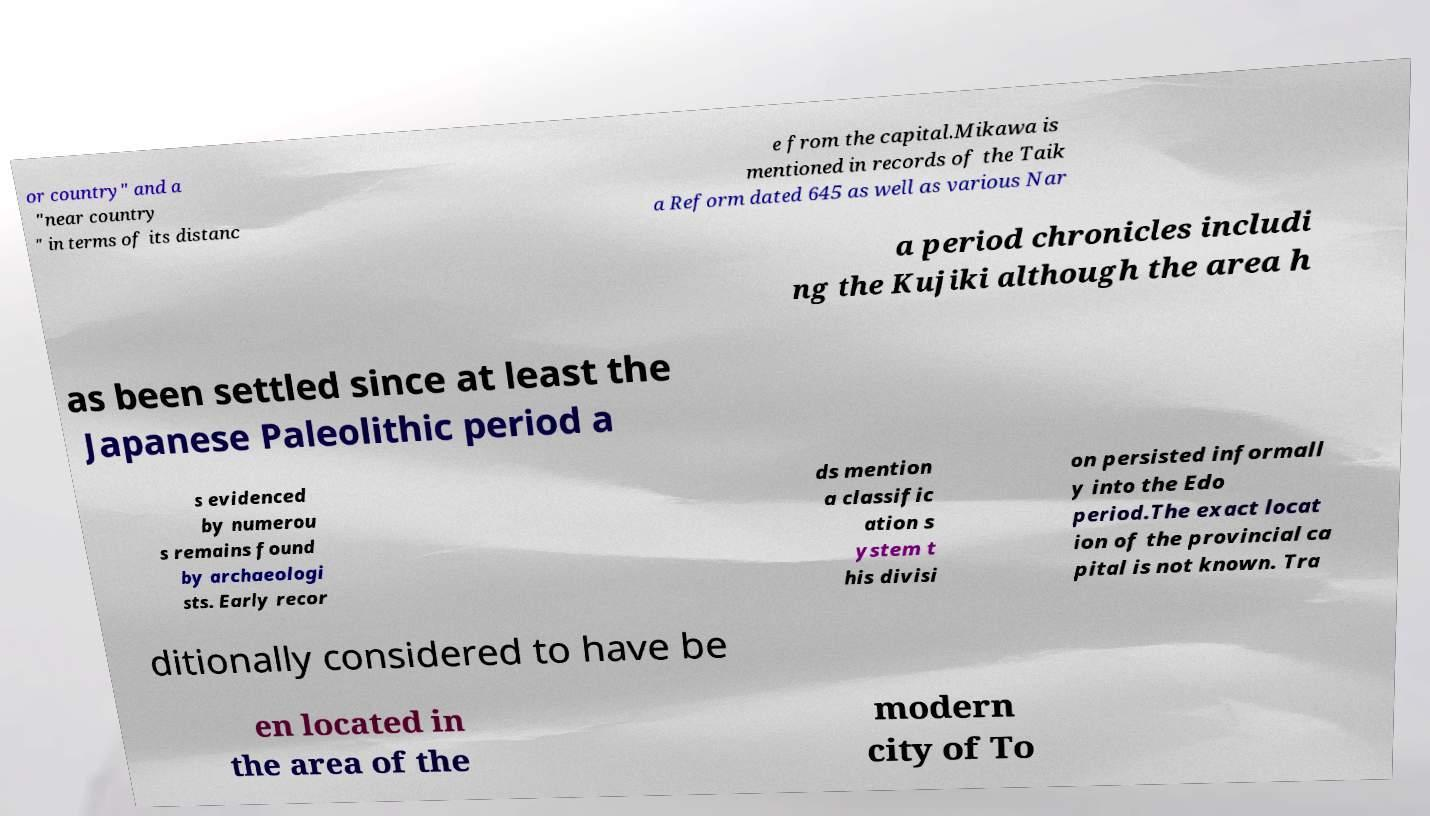Can you read and provide the text displayed in the image?This photo seems to have some interesting text. Can you extract and type it out for me? or country" and a "near country " in terms of its distanc e from the capital.Mikawa is mentioned in records of the Taik a Reform dated 645 as well as various Nar a period chronicles includi ng the Kujiki although the area h as been settled since at least the Japanese Paleolithic period a s evidenced by numerou s remains found by archaeologi sts. Early recor ds mention a classific ation s ystem t his divisi on persisted informall y into the Edo period.The exact locat ion of the provincial ca pital is not known. Tra ditionally considered to have be en located in the area of the modern city of To 